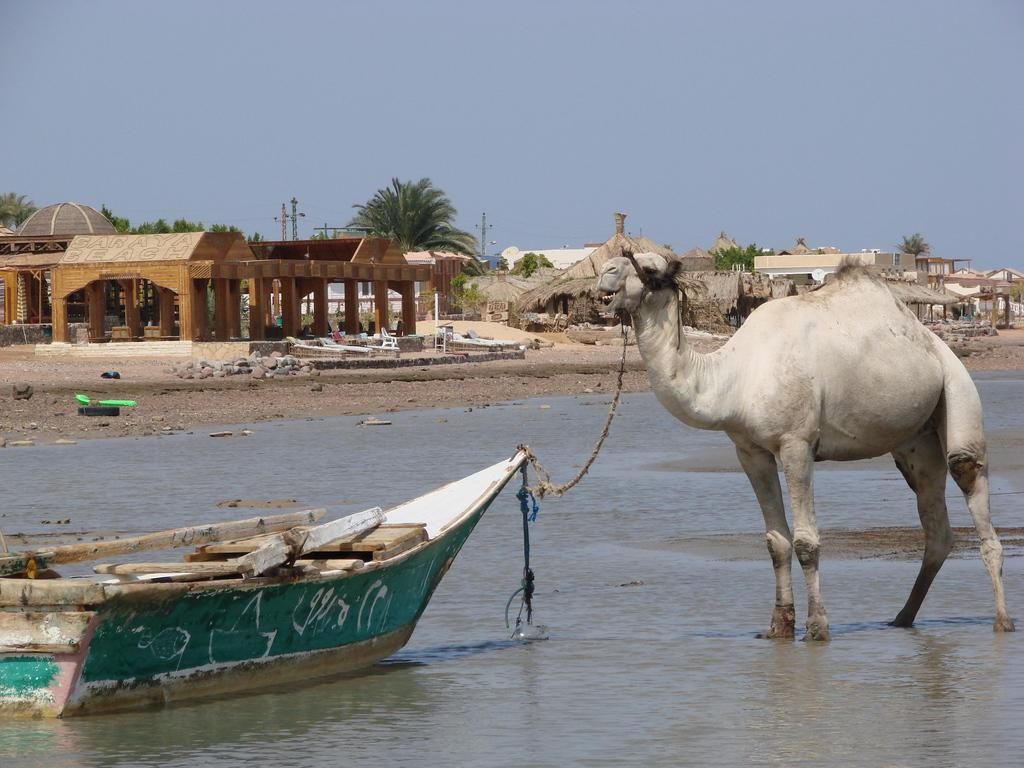What is the unusual combination of elements in the image? There is a camel tied on a boat in the image. What can be seen beneath the boat? Water is visible in the image. What type of environment is depicted in the background? There are houses, stones, trees, poles, and the sky visible in the background. What day of the week is it in the image? The day of the week is not mentioned or depicted in the image. What type of coach can be seen in the image? There is no coach present in the image. 